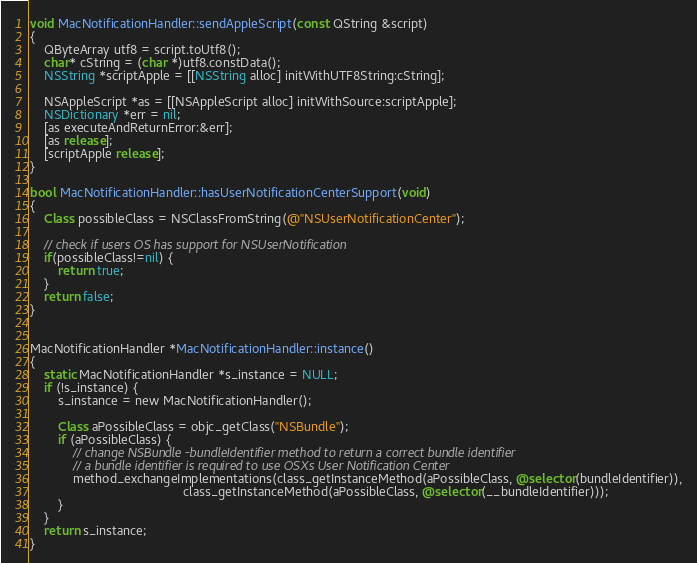<code> <loc_0><loc_0><loc_500><loc_500><_ObjectiveC_>void MacNotificationHandler::sendAppleScript(const QString &script)
{
    QByteArray utf8 = script.toUtf8();
    char* cString = (char *)utf8.constData();
    NSString *scriptApple = [[NSString alloc] initWithUTF8String:cString];

    NSAppleScript *as = [[NSAppleScript alloc] initWithSource:scriptApple];
    NSDictionary *err = nil;
    [as executeAndReturnError:&err];
    [as release];
    [scriptApple release];
}

bool MacNotificationHandler::hasUserNotificationCenterSupport(void)
{
    Class possibleClass = NSClassFromString(@"NSUserNotificationCenter");

    // check if users OS has support for NSUserNotification
    if(possibleClass!=nil) {
        return true;
    }
    return false;
}


MacNotificationHandler *MacNotificationHandler::instance()
{
    static MacNotificationHandler *s_instance = NULL;
    if (!s_instance) {
        s_instance = new MacNotificationHandler();
        
        Class aPossibleClass = objc_getClass("NSBundle");
        if (aPossibleClass) {
            // change NSBundle -bundleIdentifier method to return a correct bundle identifier
            // a bundle identifier is required to use OSXs User Notification Center
            method_exchangeImplementations(class_getInstanceMethod(aPossibleClass, @selector(bundleIdentifier)),
                                           class_getInstanceMethod(aPossibleClass, @selector(__bundleIdentifier)));
        }
    }
    return s_instance;
}
</code> 